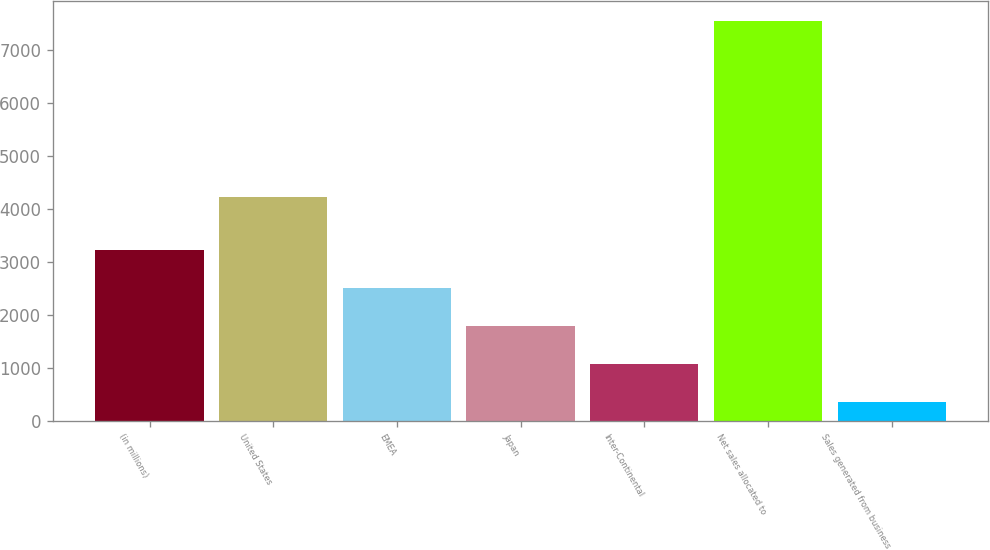<chart> <loc_0><loc_0><loc_500><loc_500><bar_chart><fcel>(in millions)<fcel>United States<fcel>EMEA<fcel>Japan<fcel>Inter-Continental<fcel>Net sales allocated to<fcel>Sales generated from business<nl><fcel>3224<fcel>4215<fcel>2504.5<fcel>1785<fcel>1065.5<fcel>7541<fcel>346<nl></chart> 